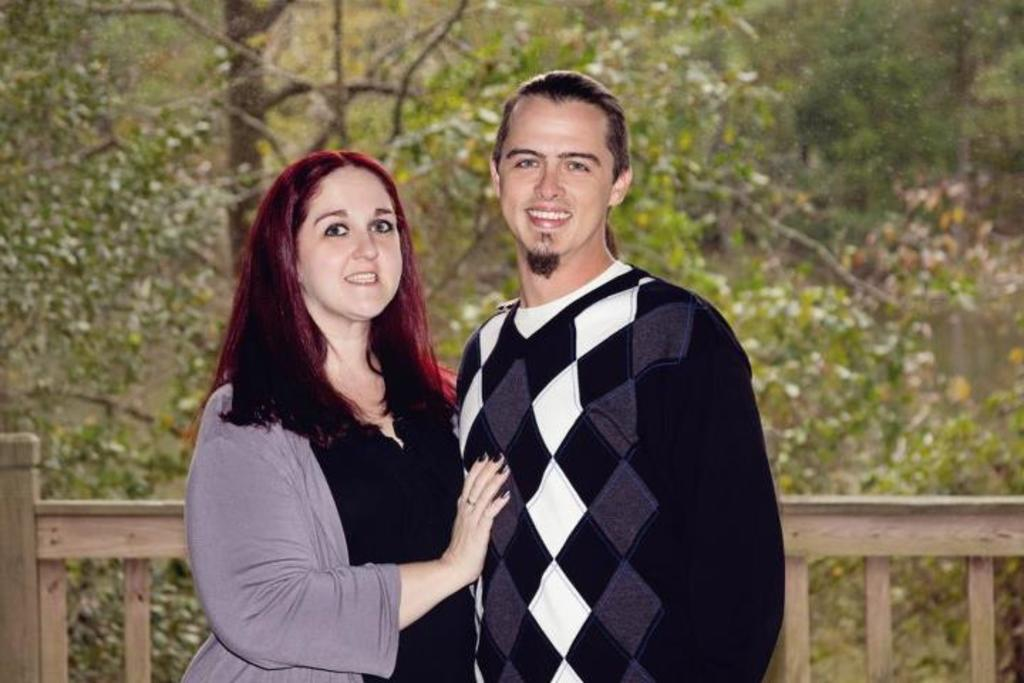How many people are in the image? There are two people in the image. What are the people doing in the image? The people are standing and smiling. What can be seen in the background of the image? There are plants and trees in the background of the image. What type of barrier is present in the image? There is a wooden fence in the image. What type of hospital can be seen in the background of the image? There is no hospital present in the image; it features two people standing and smiling, with a wooden fence and plants and trees in the background. 